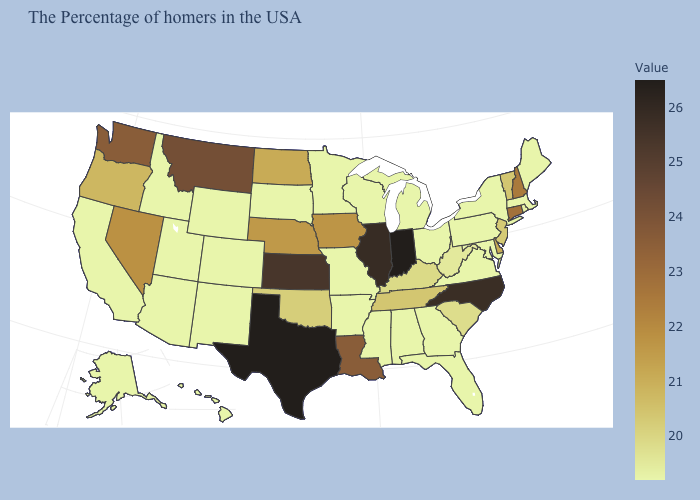Does Wyoming have the lowest value in the West?
Quick response, please. Yes. Which states have the lowest value in the South?
Keep it brief. Maryland, Virginia, Florida, Georgia, Alabama, Mississippi, Arkansas. Among the states that border Missouri , which have the lowest value?
Answer briefly. Arkansas. Does Delaware have the lowest value in the USA?
Keep it brief. No. Does Indiana have the highest value in the MidWest?
Be succinct. Yes. 